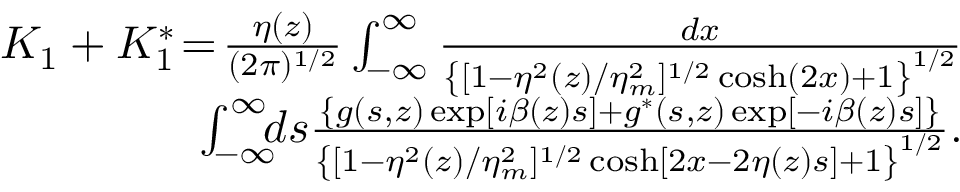<formula> <loc_0><loc_0><loc_500><loc_500>\begin{array} { r l r } & { \, K _ { 1 } + K _ { 1 } ^ { * } \, = \, \frac { \eta ( z ) } { ( 2 \pi ) ^ { 1 / 2 } } \int _ { - \infty } ^ { \infty } \frac { d x } { \left \{ [ 1 - \eta ^ { 2 } ( z ) / \eta _ { m } ^ { 2 } ] ^ { 1 / 2 } \cosh ( 2 x ) + 1 \right \} ^ { 1 / 2 } } } \\ & { \, \int _ { - \infty } ^ { \infty } \, d s \frac { \left \{ g ( s , z ) \exp [ i \beta ( z ) s ] + g ^ { * } ( s , z ) \exp [ - i \beta ( z ) s ] \right \} } { \left \{ [ 1 - \eta ^ { 2 } ( z ) / \eta _ { m } ^ { 2 } ] ^ { 1 / 2 } \cosh [ 2 x - 2 \eta ( z ) s ] + 1 \right \} ^ { 1 / 2 } } . } \end{array}</formula> 